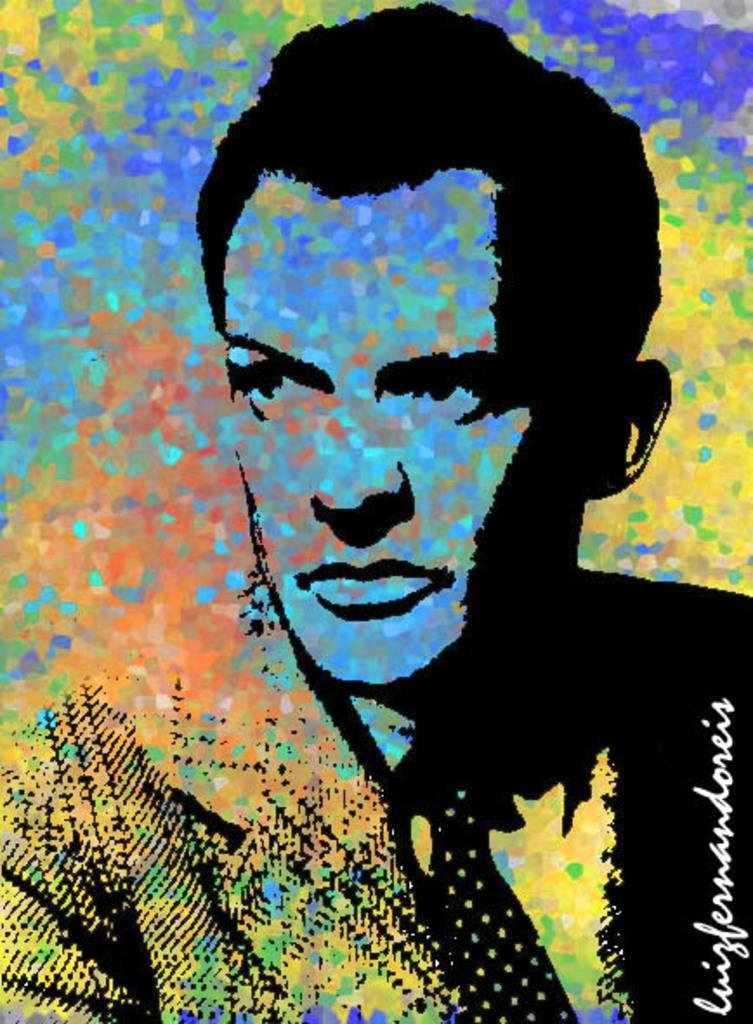What type of image is depicted in the picture? The image appears to be a poster. Who or what is the main subject of the poster? The poster features a man. Is there any additional information about the image? Yes, there is a watermark on the image. What is the name of the flock of yams in the image? There are no yams or flocks of yams present in the image. 